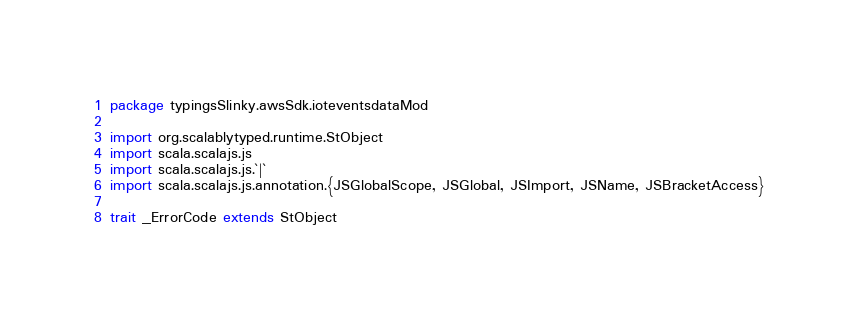Convert code to text. <code><loc_0><loc_0><loc_500><loc_500><_Scala_>package typingsSlinky.awsSdk.ioteventsdataMod

import org.scalablytyped.runtime.StObject
import scala.scalajs.js
import scala.scalajs.js.`|`
import scala.scalajs.js.annotation.{JSGlobalScope, JSGlobal, JSImport, JSName, JSBracketAccess}

trait _ErrorCode extends StObject
</code> 